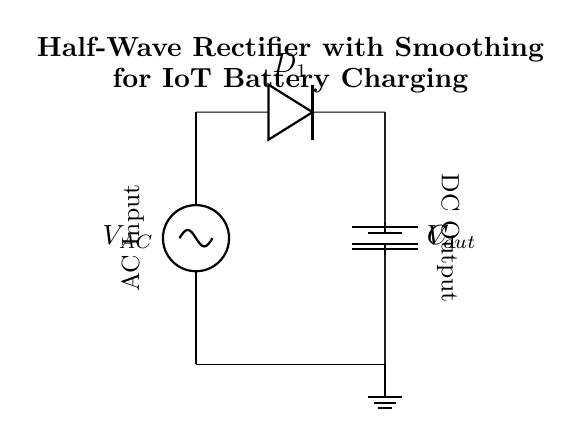What is the function of the diode in this circuit? The diode (D1) allows current to flow in one direction only, converting the AC input to a pulsating DC output by blocking the negative half-cycles of the AC waveform.
Answer: Allow current in one direction What component smooths the DC output in this circuit? The smoothing capacitor (C1) charges during the positive cycles of the rectified output and discharges during the negative cycles, reducing voltage ripple and providing a more stable DC output.
Answer: Smoothing capacitor What is the purpose of the load resistor in the circuit? The load resistor acts as a power-consuming component (such as a battery) that draws current from the output, allowing the charging of the battery which is represented in the circuit as a voltage source (Vout).
Answer: Charge the battery What type of rectifier is used in this circuit? The circuit is a half-wave rectifier, which means it only allows one half of the AC input waveform to pass through, leading to a pulsating DC output.
Answer: Half-wave rectifier What happens to the negative cycles of the AC waveform? The negative cycles of the AC waveform are blocked by the diode, preventing them from reaching the load and resulting in a zero current flow during these periods.
Answer: Blocked by the diode What is the relationship between the AC input and the DC output voltage? The DC output voltage will be less than the peak voltage of the AC input due to the voltage drop across the diode and the smoothing effect of the capacitor which prevents the output from reaching the minimum value during discharging.
Answer: Less than the peak voltage 